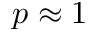Convert formula to latex. <formula><loc_0><loc_0><loc_500><loc_500>p \approx 1</formula> 